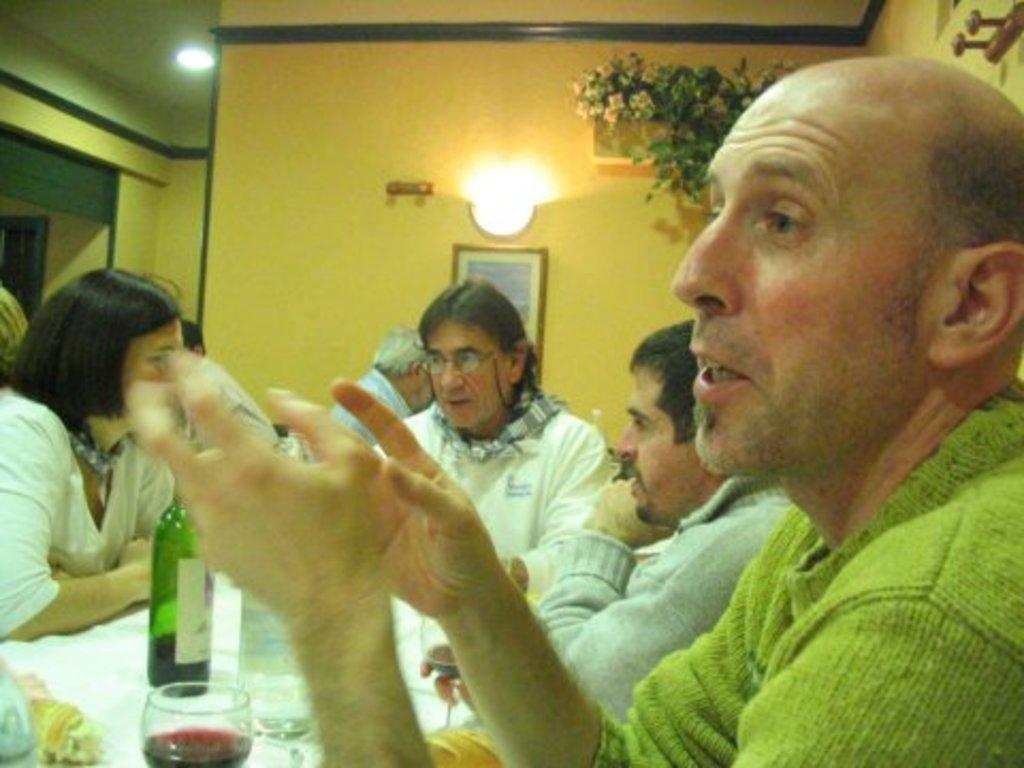What are the people in the image doing? The people in the image are sitting and talking. What is on the table in the image? There is a glass of wine and a bottle on the table. What can be seen in the background of the image? There are lights and flowers in the background of the image. What type of skate is being used by the people in the image? There is no skate present in the image; the people are sitting and talking. Can you tell me how many pieces of quartz are on the table in the image? There is no quartz present on the table in the image; there is only a glass of wine and a bottle. 